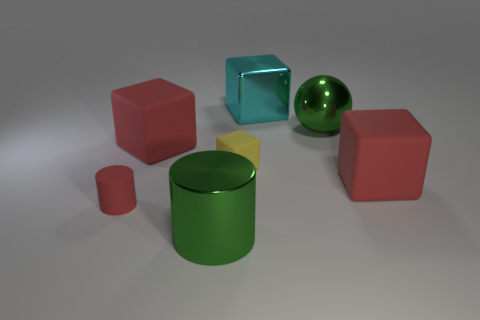Subtract all big cyan blocks. How many blocks are left? 3 Subtract all cyan blocks. How many blocks are left? 3 Add 2 red rubber cylinders. How many objects exist? 9 Subtract 1 cubes. How many cubes are left? 3 Subtract 1 yellow cubes. How many objects are left? 6 Subtract all cubes. How many objects are left? 3 Subtract all gray cubes. Subtract all red balls. How many cubes are left? 4 Subtract all red cylinders. How many cyan blocks are left? 1 Subtract all yellow shiny cylinders. Subtract all matte blocks. How many objects are left? 4 Add 7 cyan metal objects. How many cyan metal objects are left? 8 